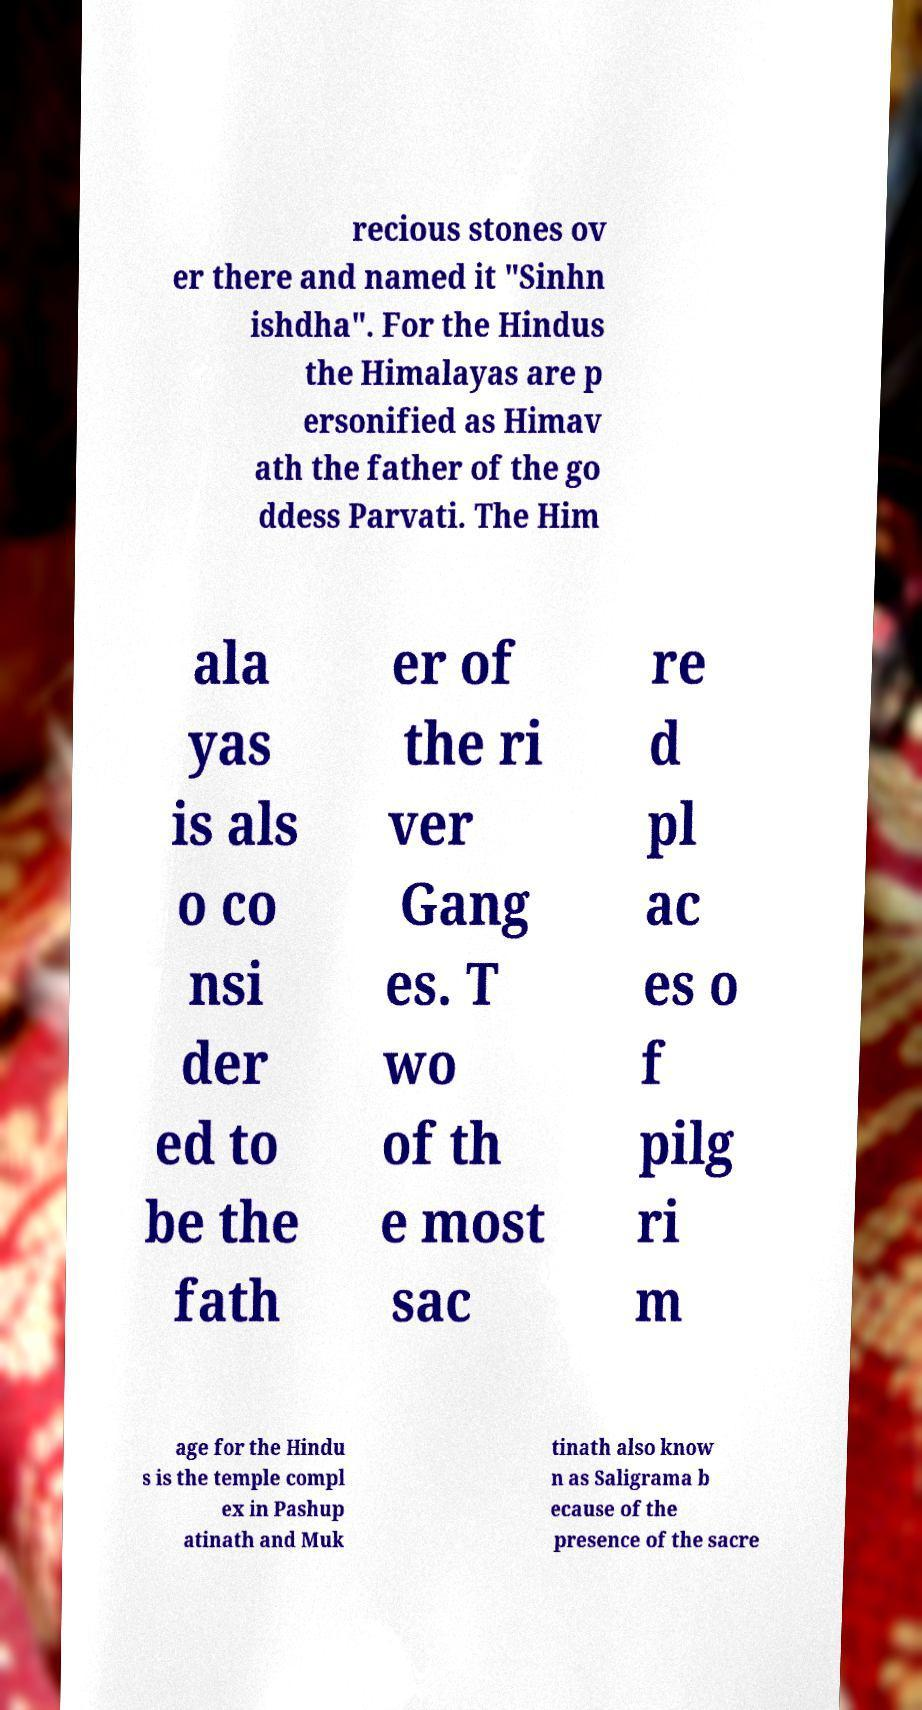Could you extract and type out the text from this image? recious stones ov er there and named it "Sinhn ishdha". For the Hindus the Himalayas are p ersonified as Himav ath the father of the go ddess Parvati. The Him ala yas is als o co nsi der ed to be the fath er of the ri ver Gang es. T wo of th e most sac re d pl ac es o f pilg ri m age for the Hindu s is the temple compl ex in Pashup atinath and Muk tinath also know n as Saligrama b ecause of the presence of the sacre 